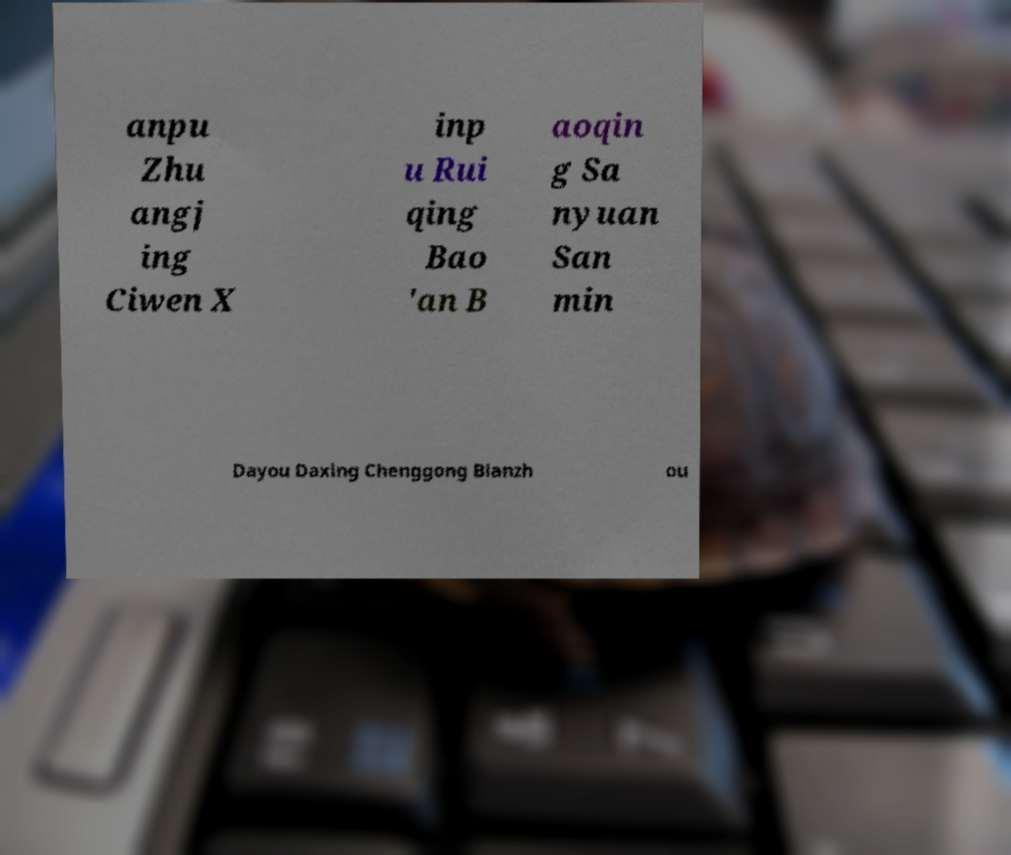Could you assist in decoding the text presented in this image and type it out clearly? anpu Zhu angj ing Ciwen X inp u Rui qing Bao 'an B aoqin g Sa nyuan San min Dayou Daxing Chenggong Bianzh ou 